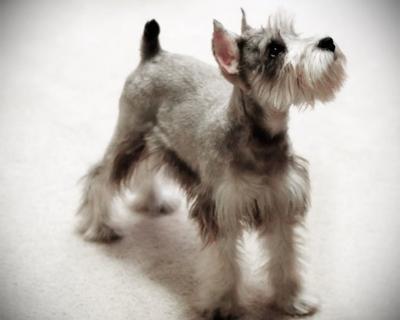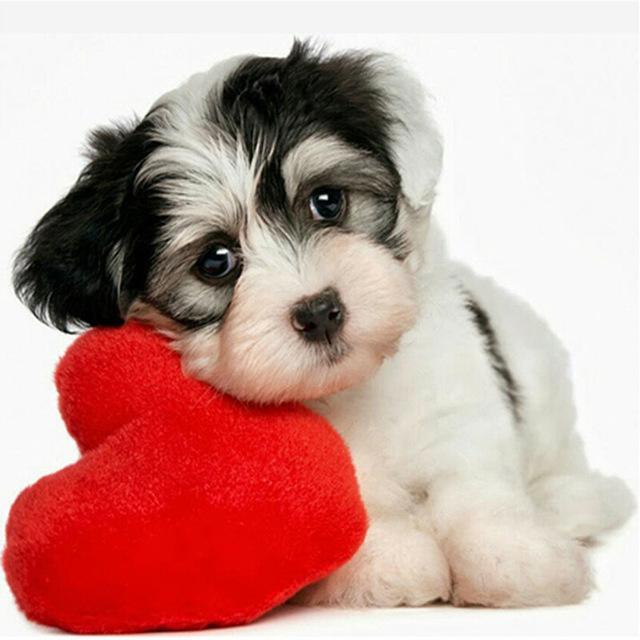The first image is the image on the left, the second image is the image on the right. For the images displayed, is the sentence "The dog in the left image is in a standing pose with body turned to the right." factually correct? Answer yes or no. Yes. 